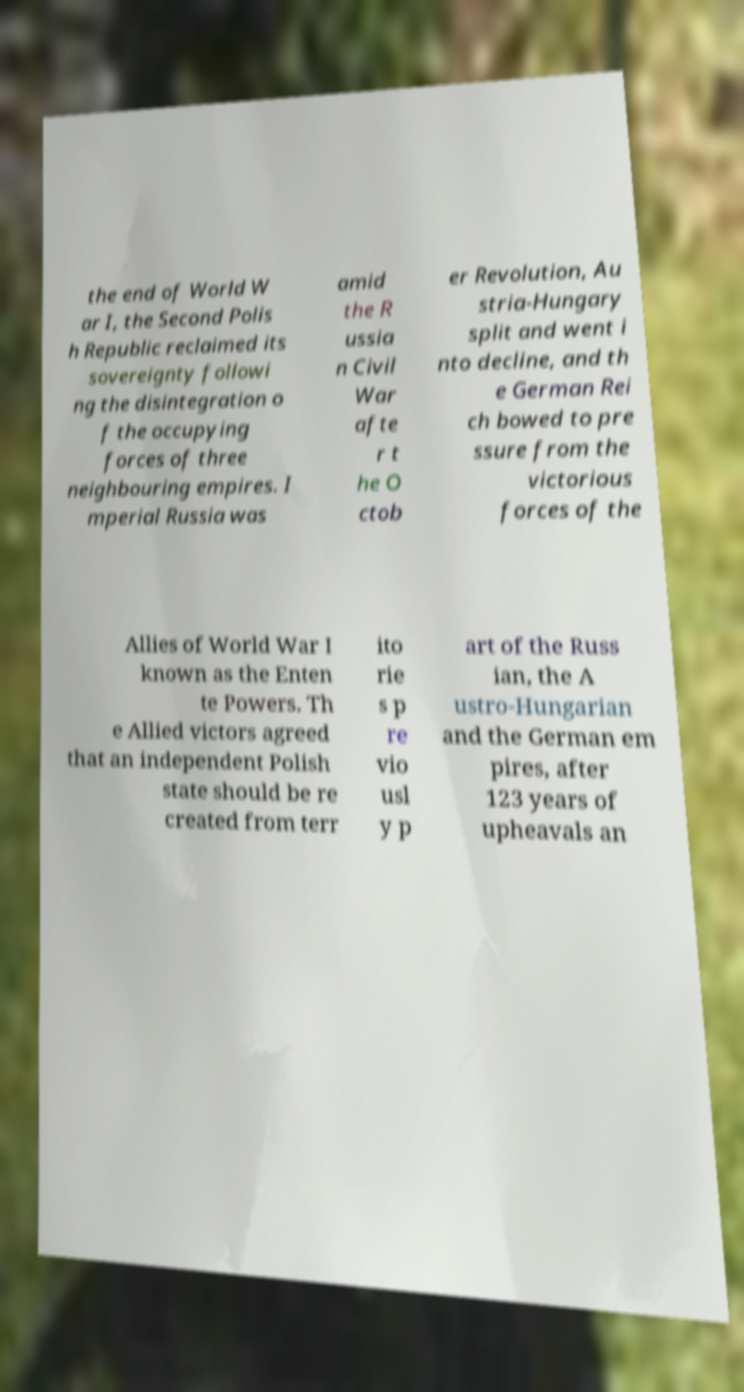There's text embedded in this image that I need extracted. Can you transcribe it verbatim? the end of World W ar I, the Second Polis h Republic reclaimed its sovereignty followi ng the disintegration o f the occupying forces of three neighbouring empires. I mperial Russia was amid the R ussia n Civil War afte r t he O ctob er Revolution, Au stria-Hungary split and went i nto decline, and th e German Rei ch bowed to pre ssure from the victorious forces of the Allies of World War I known as the Enten te Powers. Th e Allied victors agreed that an independent Polish state should be re created from terr ito rie s p re vio usl y p art of the Russ ian, the A ustro-Hungarian and the German em pires, after 123 years of upheavals an 